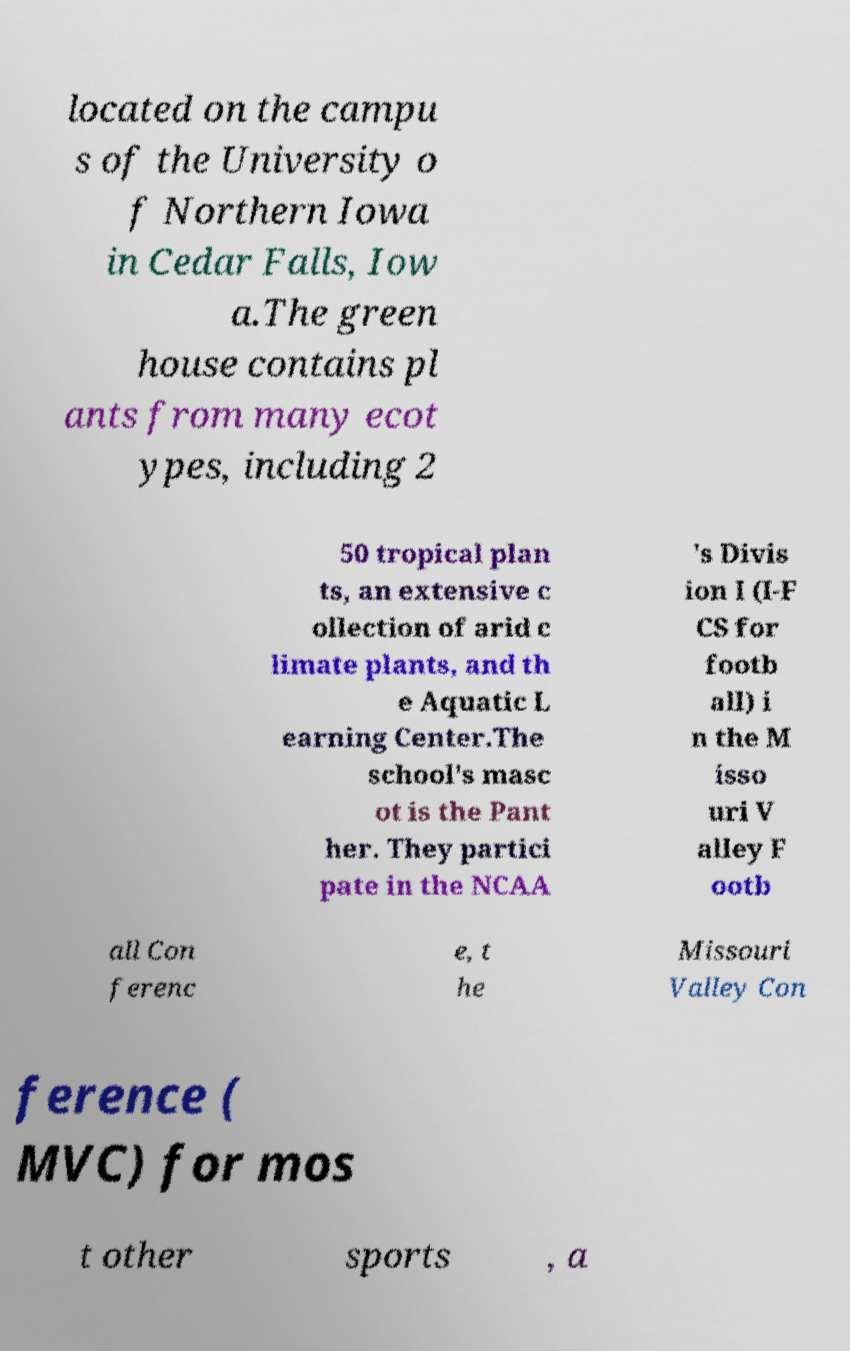There's text embedded in this image that I need extracted. Can you transcribe it verbatim? located on the campu s of the University o f Northern Iowa in Cedar Falls, Iow a.The green house contains pl ants from many ecot ypes, including 2 50 tropical plan ts, an extensive c ollection of arid c limate plants, and th e Aquatic L earning Center.The school's masc ot is the Pant her. They partici pate in the NCAA 's Divis ion I (I-F CS for footb all) i n the M isso uri V alley F ootb all Con ferenc e, t he Missouri Valley Con ference ( MVC) for mos t other sports , a 